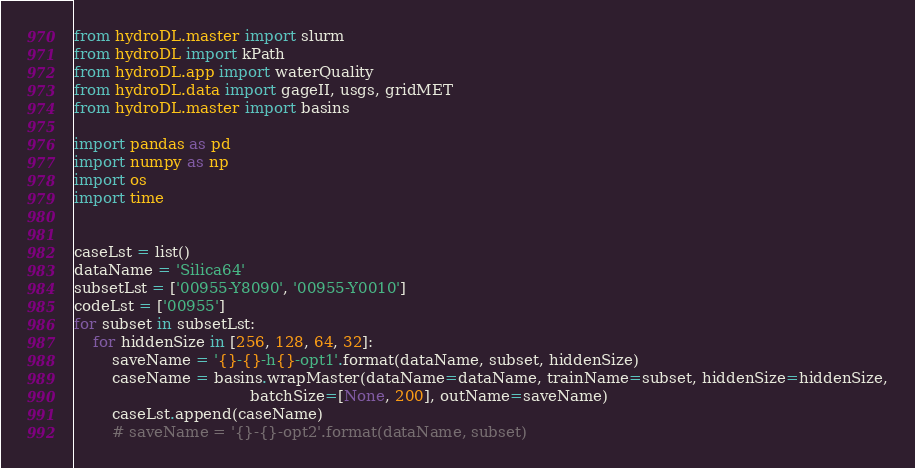<code> <loc_0><loc_0><loc_500><loc_500><_Python_>from hydroDL.master import slurm
from hydroDL import kPath
from hydroDL.app import waterQuality
from hydroDL.data import gageII, usgs, gridMET
from hydroDL.master import basins

import pandas as pd
import numpy as np
import os
import time


caseLst = list()
dataName = 'Silica64'
subsetLst = ['00955-Y8090', '00955-Y0010']
codeLst = ['00955']
for subset in subsetLst:
    for hiddenSize in [256, 128, 64, 32]:
        saveName = '{}-{}-h{}-opt1'.format(dataName, subset, hiddenSize)
        caseName = basins.wrapMaster(dataName=dataName, trainName=subset, hiddenSize=hiddenSize,
                                     batchSize=[None, 200], outName=saveName)
        caseLst.append(caseName)
        # saveName = '{}-{}-opt2'.format(dataName, subset)</code> 